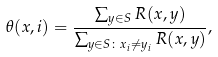<formula> <loc_0><loc_0><loc_500><loc_500>\theta ( x , i ) = \frac { \sum _ { y \in S } R ( x , y ) } { \sum _ { y \in S \colon x _ { i } \neq y _ { i } } R ( x , y ) } ,</formula> 